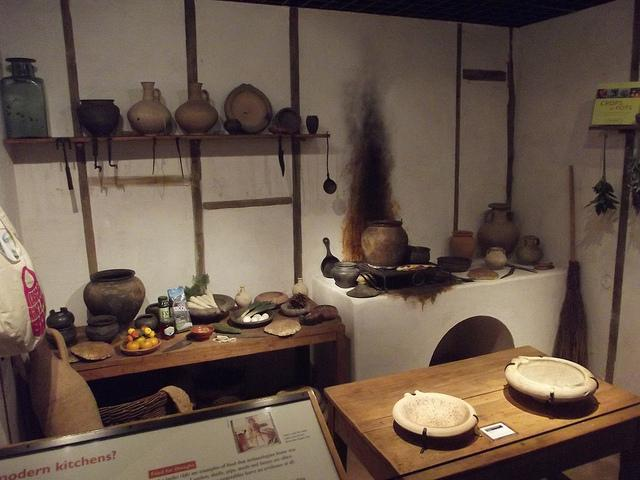In what type building is this located?

Choices:
A) gym
B) museum
C) basketball hall
D) residence museum 